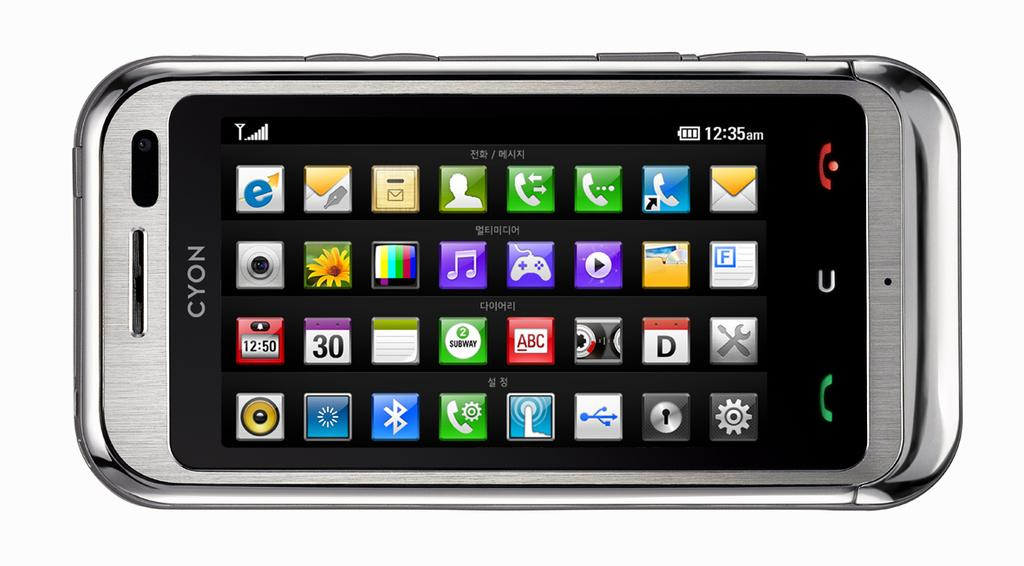Provide a one-sentence caption for the provided image. an old looking phone with the word cyon along the top. 